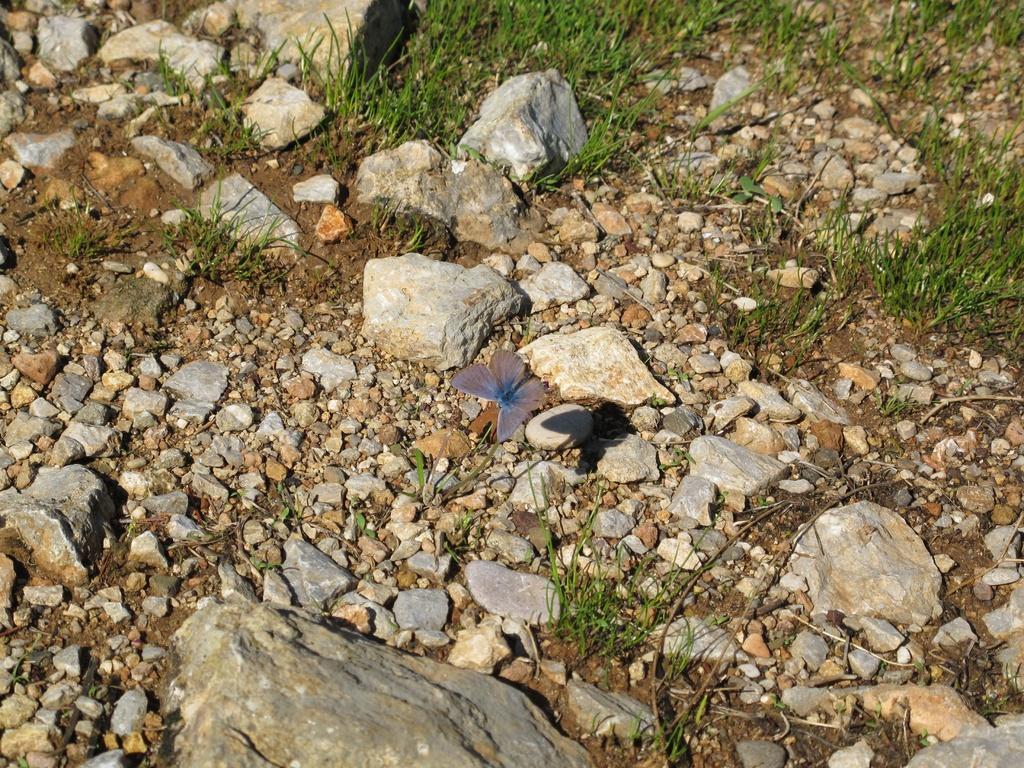Could you give a brief overview of what you see in this image? In this image there is a butterfly under that there are so many stones and grass on the ground. 